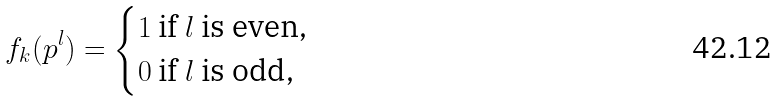<formula> <loc_0><loc_0><loc_500><loc_500>f _ { k } ( p ^ { l } ) = \begin{cases} 1 \text { if $l$ is even,} \\ 0 \text { if $l$ is odd,} \end{cases}</formula> 